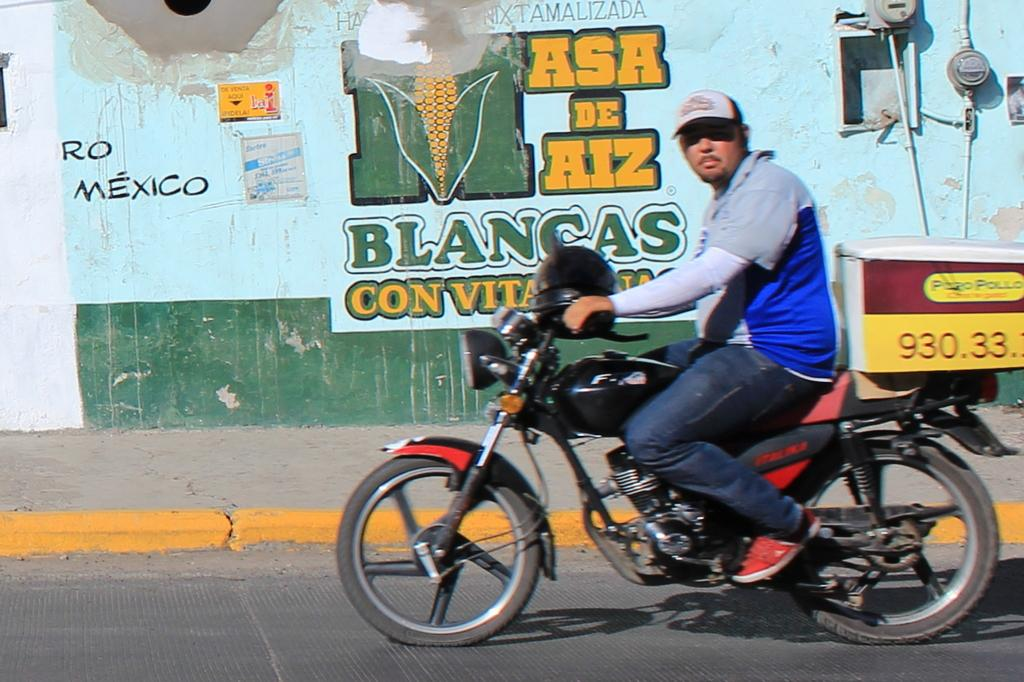What is the main subject of the image? The main subject of the image is a guy riding a bike. What safety precaution is the guy taking while riding the bike? The guy is wearing a helmet. What can be seen in the background of the image? There are many arts on a wall in the background of the image. What type of pest can be seen crawling on the guy's helmet in the image? There are no pests visible on the guy's helmet in the image. 